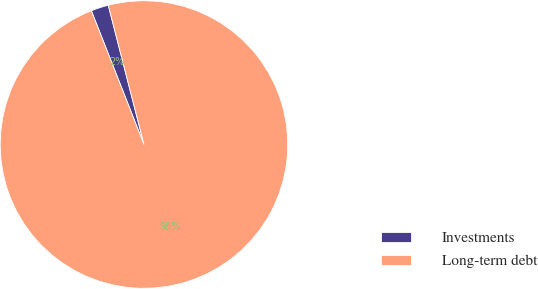Convert chart. <chart><loc_0><loc_0><loc_500><loc_500><pie_chart><fcel>Investments<fcel>Long-term debt<nl><fcel>1.97%<fcel>98.03%<nl></chart> 